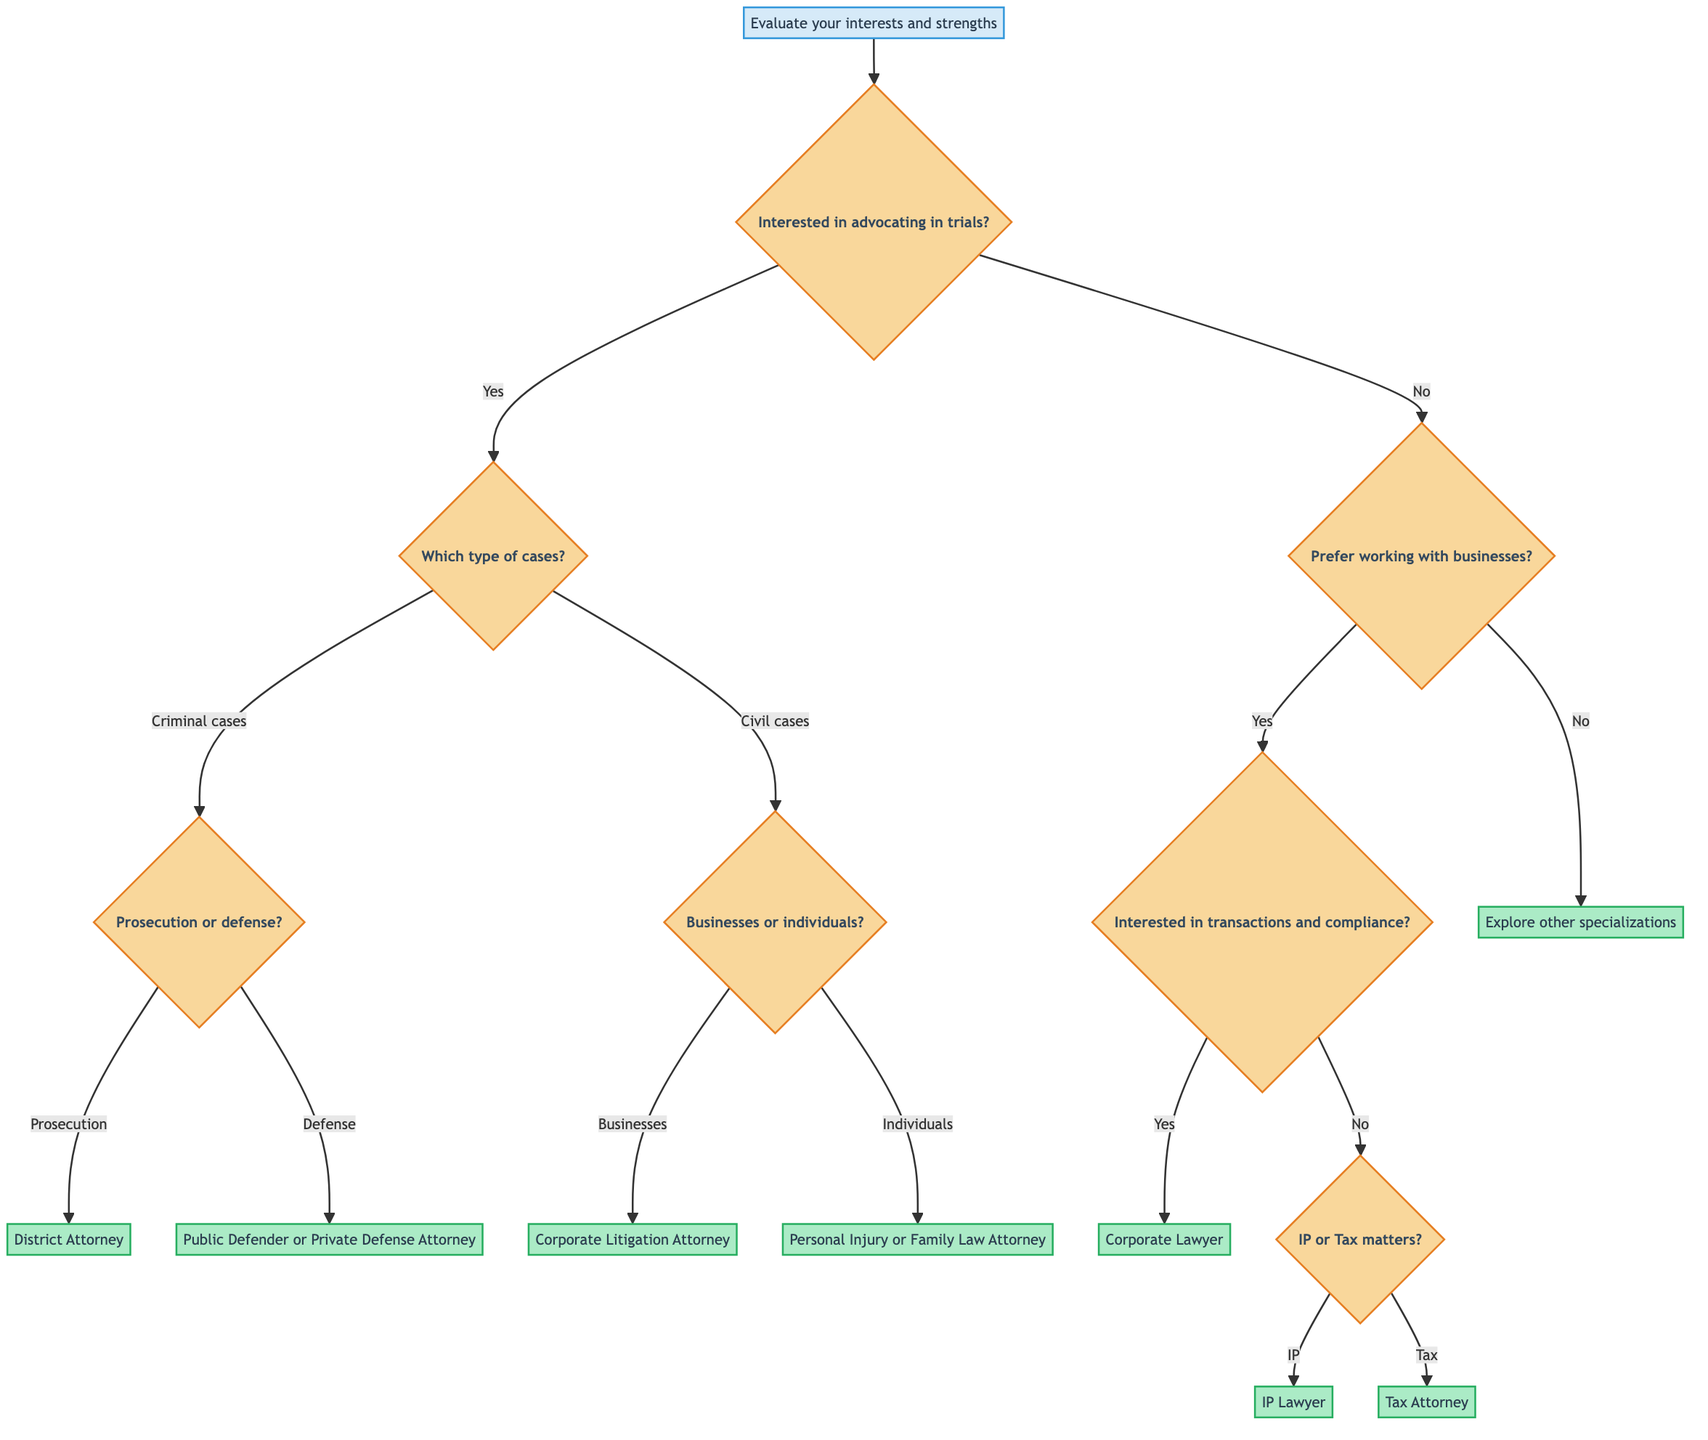What is the first step in the decision tree? The diagram starts with the node labeled "Evaluate your interests and strengths," which is the first point of consideration for anyone exploring legal career pathways.
Answer: Evaluate your interests and strengths How many branches come from the node that asks if the person is interested in advocating in trials? There are two branches that come from this node: one for "Yes" leading to the question about the type of cases, and one for "No" leading to the question about preferring to work with businesses.
Answer: Two branches What type of law should one choose if their answer is "Individuals" in the civil cases question? If the answer is "Individuals," the next node specifies options related to Personal Injury or Family Law, which indicates that choosing this path leads to either type of law.
Answer: Personal Injury or Family Law If someone answers "No" to preferring to work with businesses, what does the diagram suggest? The diagram indicates that if the answer is "No," the person should explore other specializations like Environmental Law or Immigration Law, suggesting alternative paths in the legal field.
Answer: Explore other specializations What qualifications are required for becoming a Tax Attorney according to the diagram? To become a Tax Attorney, one must have the qualifications including a JD Degree, passing the State Bar Exam, and optionally having an LLM in Taxation, as stated at the tax matters branching in the tree.
Answer: JD Degree, Pass State Bar Exam, LLM in Taxation (optional) What potential outcomes are listed for someone pursuing a career as an IP Lawyer? The diagram lists that the potential outcomes for becoming an IP Lawyer include roles as an IP Attorney or a Patent Lawyer, which are the final career paths connected to that specialization.
Answer: IP Attorney, Patent Lawyer What should a person select if they are interested in criminal cases but want to focus on defense? If a person is interested in criminal cases and chooses to focus on defense, they should follow the path leading to "Public Defender or Private Defense Attorney," which specifies this particular career focus in criminal law.
Answer: Public Defender or Private Defense Attorney How does the diagram categorize law focusing on business transactions? The diagram categorizes law focusing on business transactions under "Corporate Lawyer," which indicates specialization in this area, with specific qualifications and outcomes associated with it.
Answer: Corporate Lawyer 